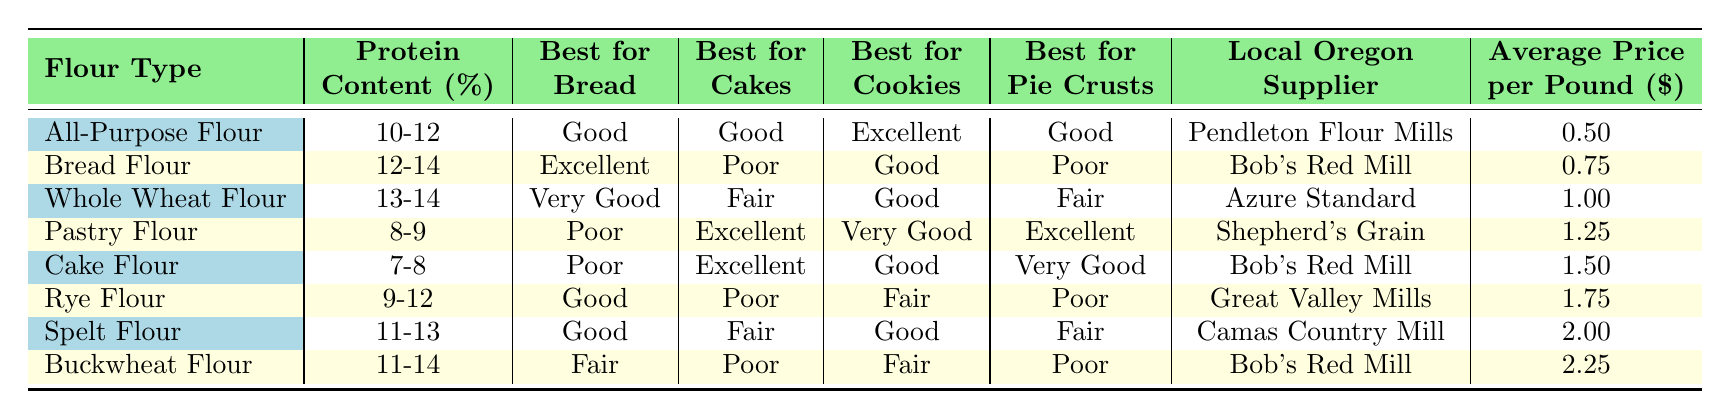What is the protein content range for Cake Flour? By referring to the table under the "Protein Content (%)" column for Cake Flour, it shows the values are between 7-8%.
Answer: 7-8% Which flour type is best for making bread? The "Best for Bread" column indicates that Bread Flour has the highest rating of "Excellent" for bread making.
Answer: Bread Flour What is the average price per pound of Rye Flour? From the "Average Price per Pound ($)" column, Rye Flour is listed at $1.75 per pound.
Answer: $1.75 Is Whole Wheat Flour good for making cakes? According to the "Best for Cakes" column, Whole Wheat Flour is rated "Fair," which means it’s not considered a top choice for cakes.
Answer: No Which flour type offers the best combination for cookies and pie crusts? Analyzing both the "Best for Cookies" and "Best for Pie Crusts," All-Purpose Flour is "Excellent" for cookies and "Good" for pie crusts, while Pastry Flour is "Very Good" for cookies and "Excellent" for pie crusts. Therefore, the best combination is subjective, but All-Purpose Flour is very versatile.
Answer: All-Purpose Flour What is the difference in average price between Cake Flour and All-Purpose Flour? The average price for Cake Flour is $1.50 and for All-Purpose Flour is $0.50. The difference is $1.50 - $0.50 = $1.00.
Answer: $1.00 Which flour is the most expensive, and what is its price? Buckwheat Flour has the highest price listed at $2.25 per pound, making it the most expensive.
Answer: $2.25 Can you find a flour suitable for both bread and pie crusts? Looking at the table, Spelt Flour has "Good" for bread and "Fair" for pie crusts, indicating it can be suitable for both, although not ideally praised.
Answer: Yes How many flour types have a protein content of 12% or more? The table lists Bread Flour (12-14), Whole Wheat Flour (13-14), Rye Flour (9-12), Spelt Flour (11-13), and Buckwheat Flour (11-14), which totals five flour types.
Answer: 5 Which local Oregon supplier provides Whole Wheat Flour? The table reveals that Whole Wheat Flour is supplied by Azure Standard.
Answer: Azure Standard Which flour is the best for cookies and also available from Bob's Red Mill? The table shows that both All-Purpose Flour and Bread Flour are from Bob's Red Mill, with All-Purpose Flour rated "Excellent" for cookies.
Answer: All-Purpose Flour 